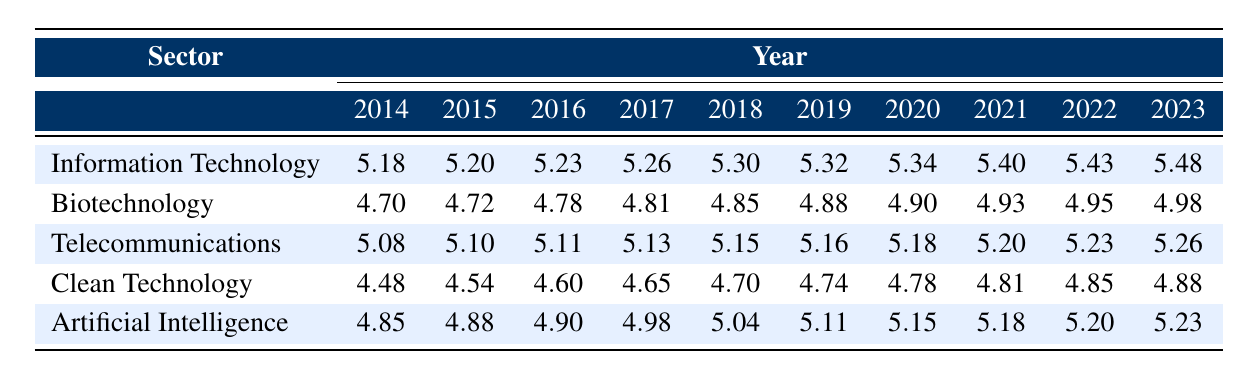What was the logarithmic value of global patent filings in the Biotechnology sector in 2020? The table shows that the value for the Biotechnology sector in 2020 is listed as 4.90.
Answer: 4.90 Which sector had the highest logarithmic value in 2023? Looking at the values for all sectors in 2023, Information Technology has the highest value of 5.48.
Answer: Information Technology What is the difference between the logarithmic value of Clean Technology in 2014 and 2023? The values for Clean Technology in 2014 and 2023 are 4.48 and 4.88, respectively. The difference is calculated as 4.88 - 4.48 = 0.40.
Answer: 0.40 Is the logarithmic value for Artificial Intelligence in 2016 greater than that of Telecommunications in the same year? In 2016, the value for Artificial Intelligence is 4.90, and for Telecommunications, it is 5.11. Since 4.90 is less than 5.11, the statement is false.
Answer: No What was the average logarithmic value of patent filings across all sectors in 2019? First, we sum the values for 2019 across all sectors: 5.32 (IT) + 4.88 (Biotech) + 5.16 (Telecom) + 4.74 (Clean Technology) + 5.11 (AI) = 25.21. There are five sectors, so the average is 25.21 / 5 = 5.04.
Answer: 5.04 In which year did biotechnology experience its highest logarithmic value? Looking at the Biotechnology sector values, the highest is in 2023 with a value of 4.98.
Answer: 2023 How many more patent filings in logarithmic values did Information Technology have compared to Clean Technology in 2022? The logarithmic values for Information Technology and Clean Technology in 2022 are 5.43 and 4.85, respectively. The difference is 5.43 - 4.85 = 0.58.
Answer: 0.58 Which sector showed the smallest growth in logarithmic values from 2014 to 2023? To determine the growth for each sector, we calculate the difference between the 2014 and 2023 values: Information Technology (5.48 - 5.18 = 0.30), Biotechnology (4.98 - 4.70 = 0.28), Telecommunications (5.26 - 5.08 = 0.18), Clean Technology (4.88 - 4.48 = 0.40), and Artificial Intelligence (5.23 - 4.85 = 0.38). The smallest growth is in Telecommunications with 0.18.
Answer: Telecommunications 